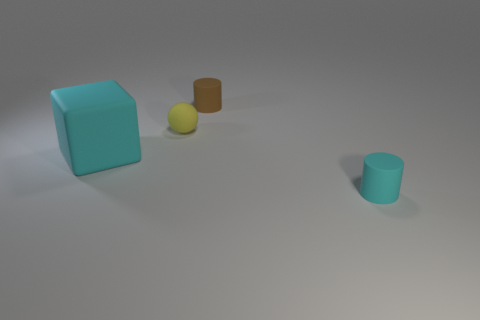Add 2 cyan blocks. How many objects exist? 6 Subtract all blocks. How many objects are left? 3 Add 1 big cyan rubber cubes. How many big cyan rubber cubes are left? 2 Add 1 yellow things. How many yellow things exist? 2 Subtract 0 blue cylinders. How many objects are left? 4 Subtract all yellow matte objects. Subtract all rubber cubes. How many objects are left? 2 